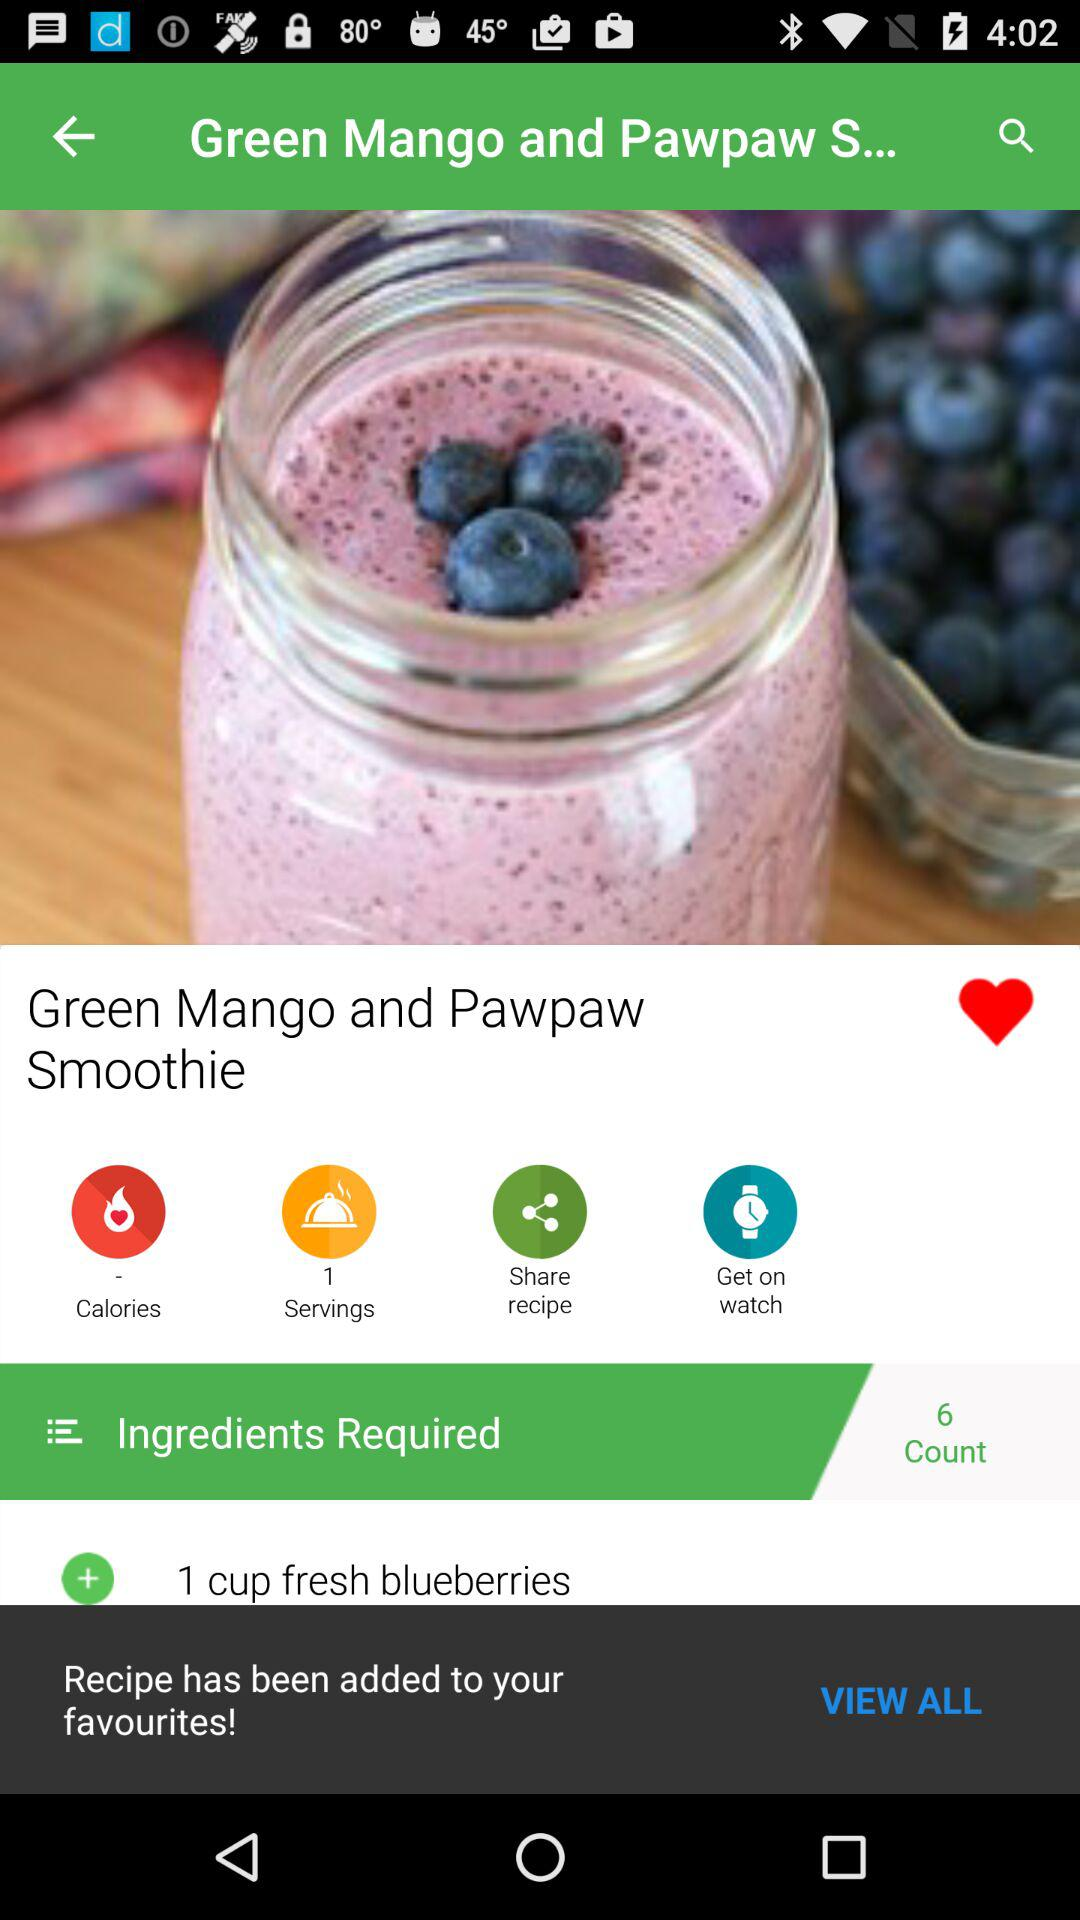How many ingredients are required? The number of required ingredients is 6. 